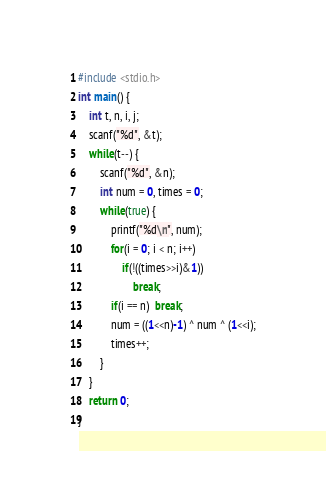Convert code to text. <code><loc_0><loc_0><loc_500><loc_500><_C++_>#include <stdio.h>
int main() {
    int t, n, i, j;
    scanf("%d", &t);
    while(t--) {
        scanf("%d", &n);
        int num = 0, times = 0;
        while(true) {
            printf("%d\n", num);
            for(i = 0; i < n; i++)
                if(!((times>>i)&1))
                    break;
            if(i == n)  break;
            num = ((1<<n)-1) ^ num ^ (1<<i);
            times++;
        }
    }
    return 0;
}
</code> 